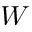Convert formula to latex. <formula><loc_0><loc_0><loc_500><loc_500>W</formula> 